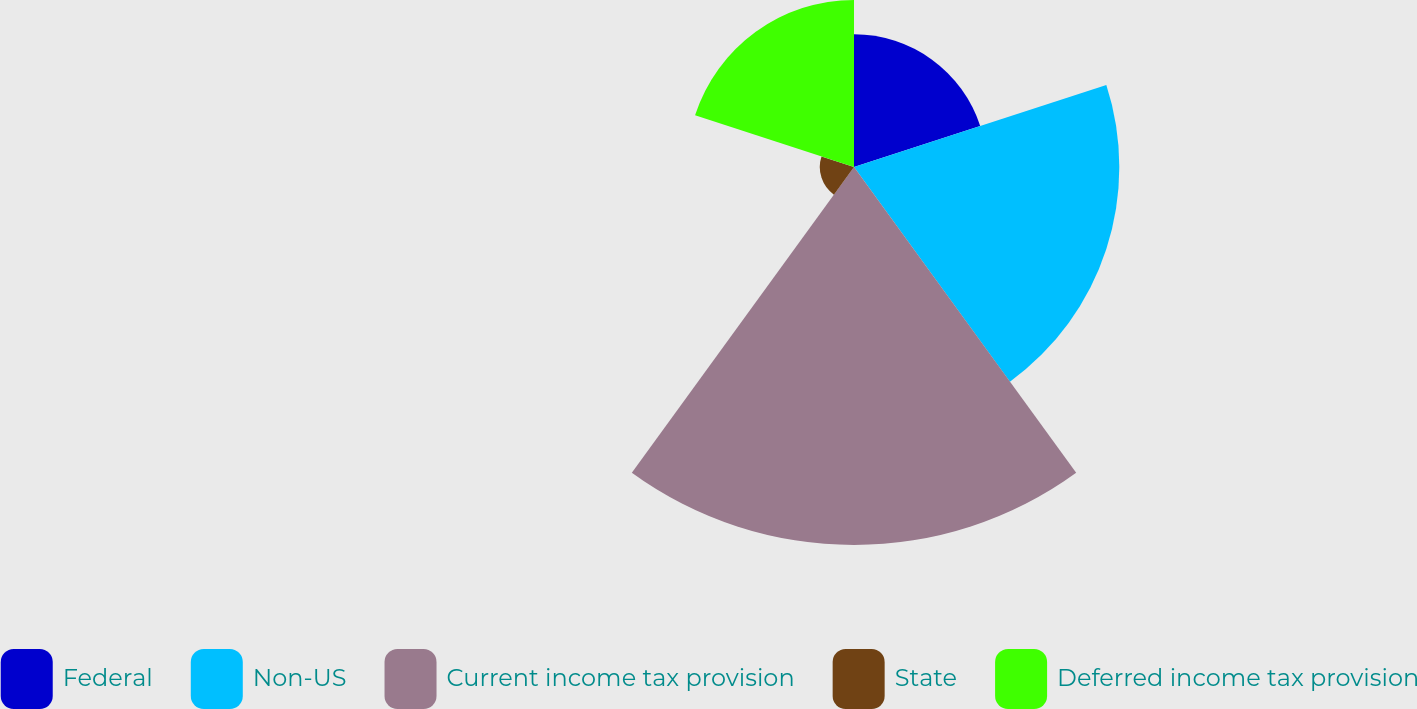Convert chart. <chart><loc_0><loc_0><loc_500><loc_500><pie_chart><fcel>Federal<fcel>Non-US<fcel>Current income tax provision<fcel>State<fcel>Deferred income tax provision<nl><fcel>13.58%<fcel>27.15%<fcel>38.68%<fcel>3.5%<fcel>17.1%<nl></chart> 